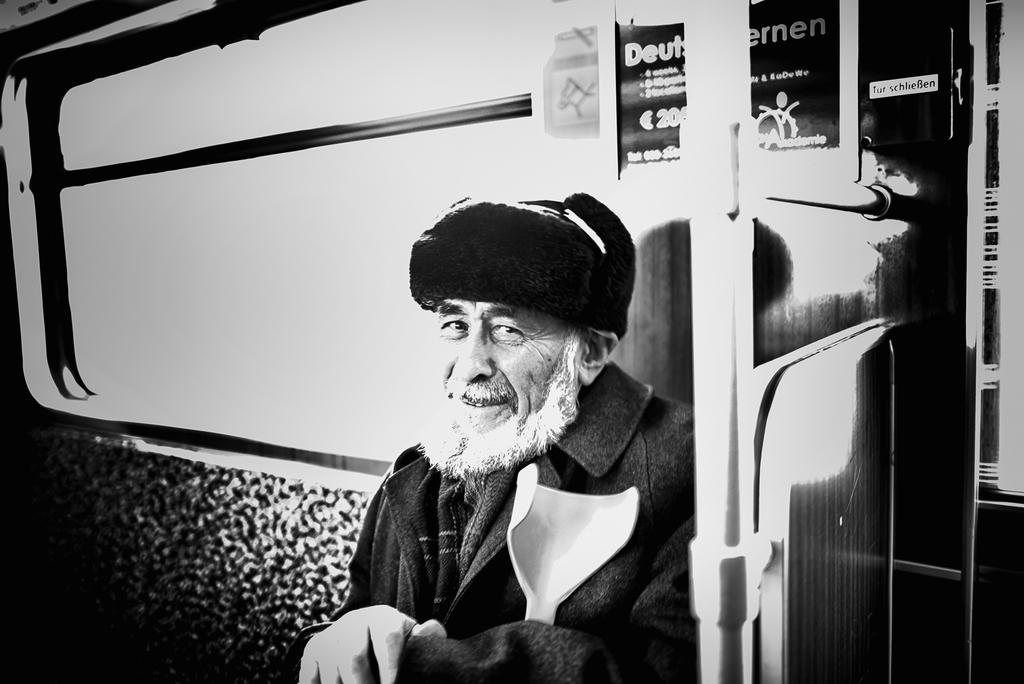What is the color scheme of the image? The image is black and white. What is the man in the image doing? The man is sitting in the image. What can be seen behind the man? There is a window and a banner behind the man. What is on the right side of the image? There is a pole on the right side of the image. How many horses can be seen in the image? There are no horses present in the image. What type of fish is swimming behind the man in the image? There are no fish present in the image. 